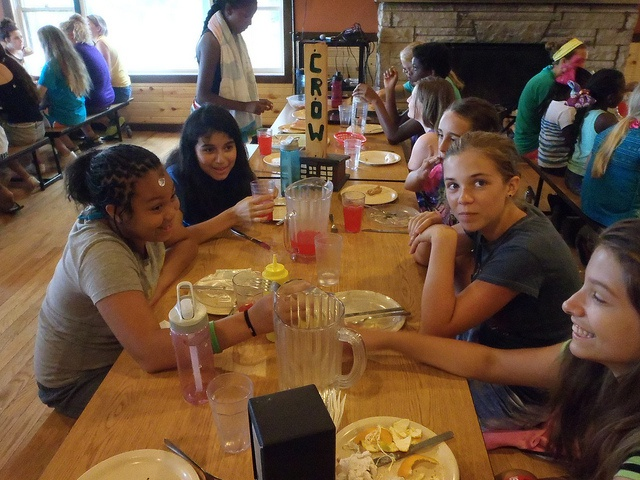Describe the objects in this image and their specific colors. I can see dining table in gray, brown, maroon, and black tones, people in gray, black, and maroon tones, people in gray, black, maroon, and brown tones, people in gray, black, brown, and maroon tones, and people in gray, black, teal, and maroon tones in this image. 